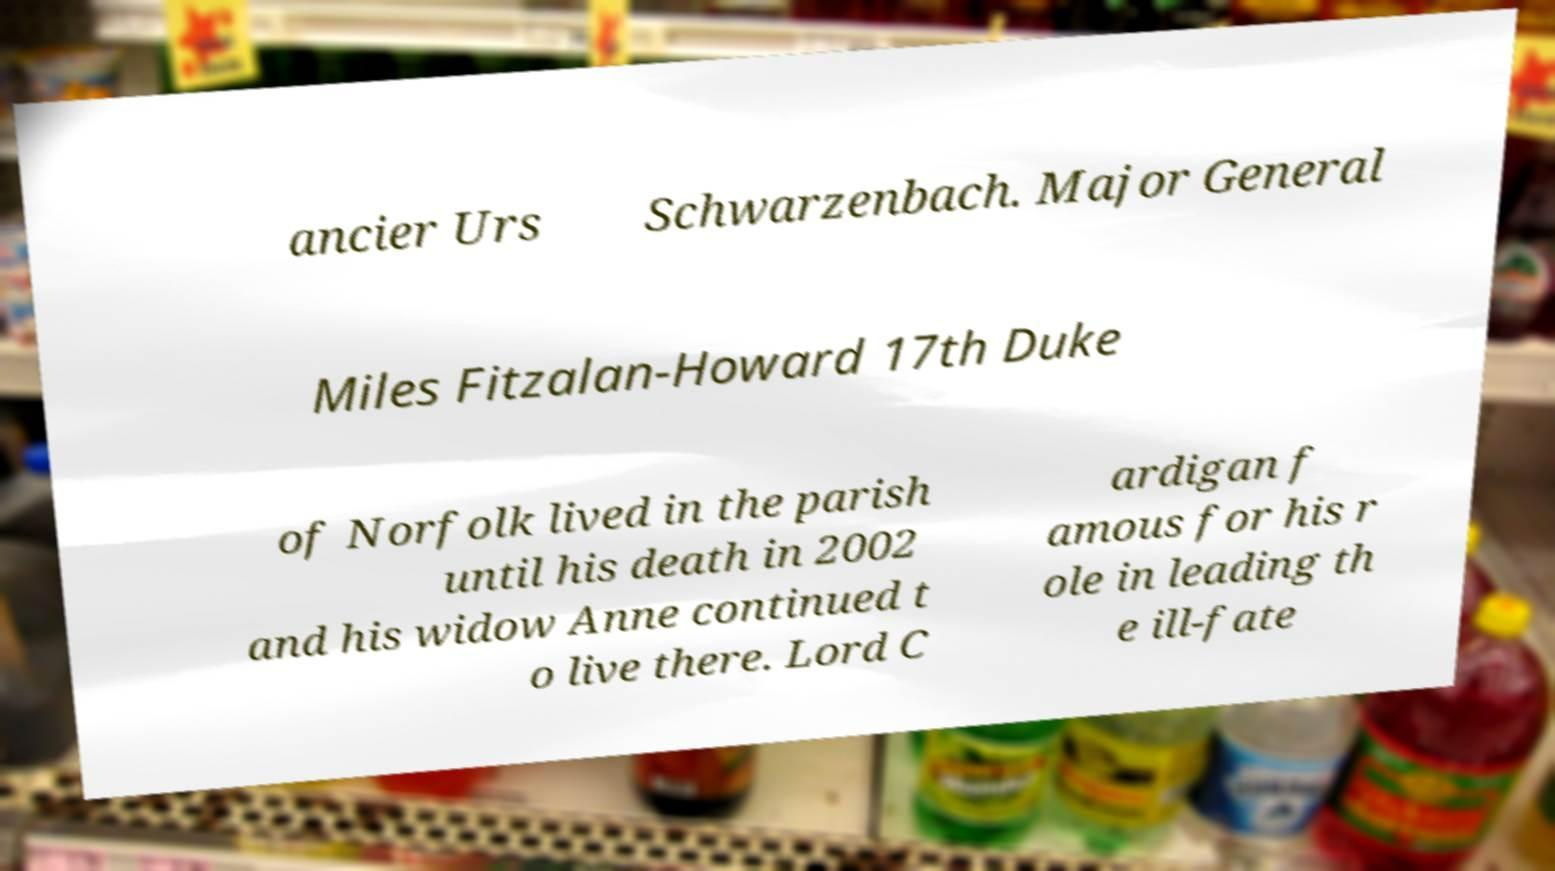I need the written content from this picture converted into text. Can you do that? ancier Urs Schwarzenbach. Major General Miles Fitzalan-Howard 17th Duke of Norfolk lived in the parish until his death in 2002 and his widow Anne continued t o live there. Lord C ardigan f amous for his r ole in leading th e ill-fate 